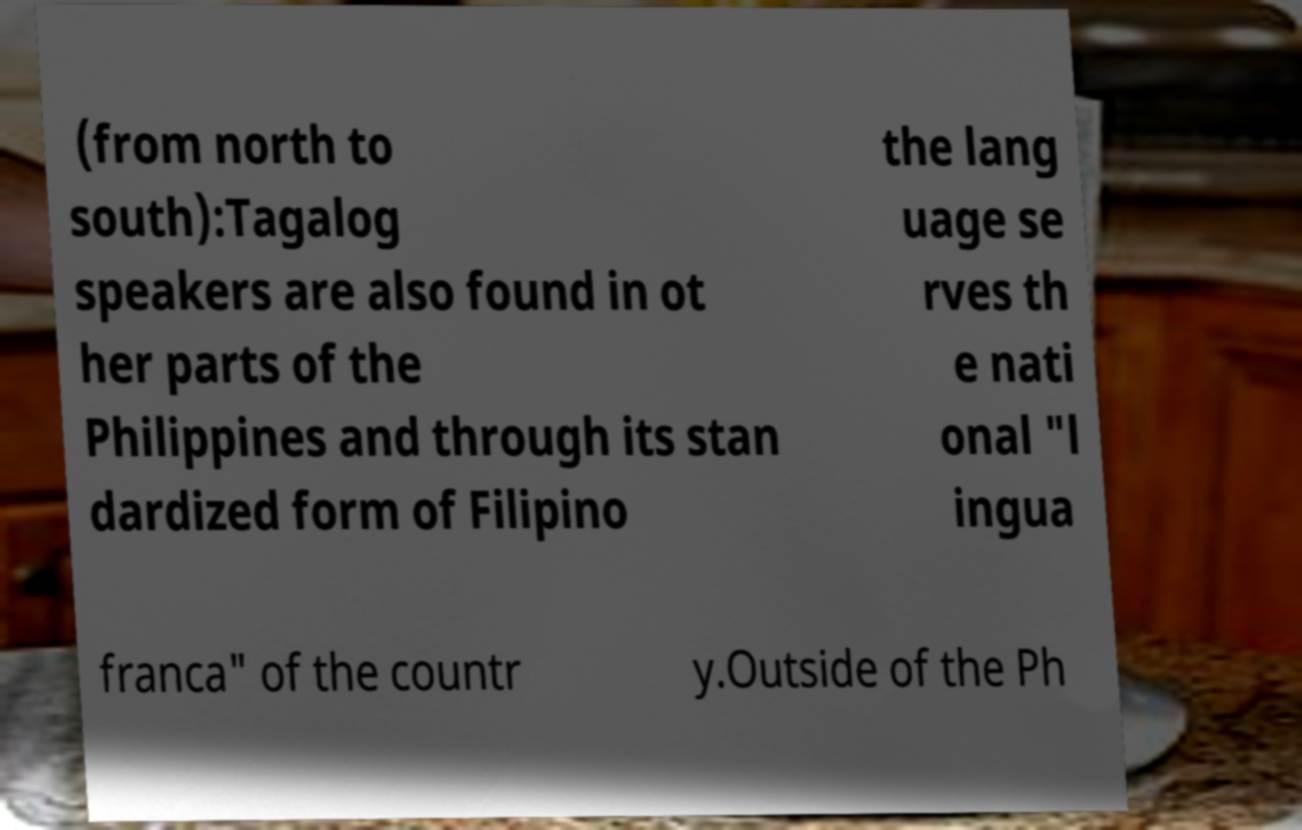Please identify and transcribe the text found in this image. (from north to south):Tagalog speakers are also found in ot her parts of the Philippines and through its stan dardized form of Filipino the lang uage se rves th e nati onal "l ingua franca" of the countr y.Outside of the Ph 